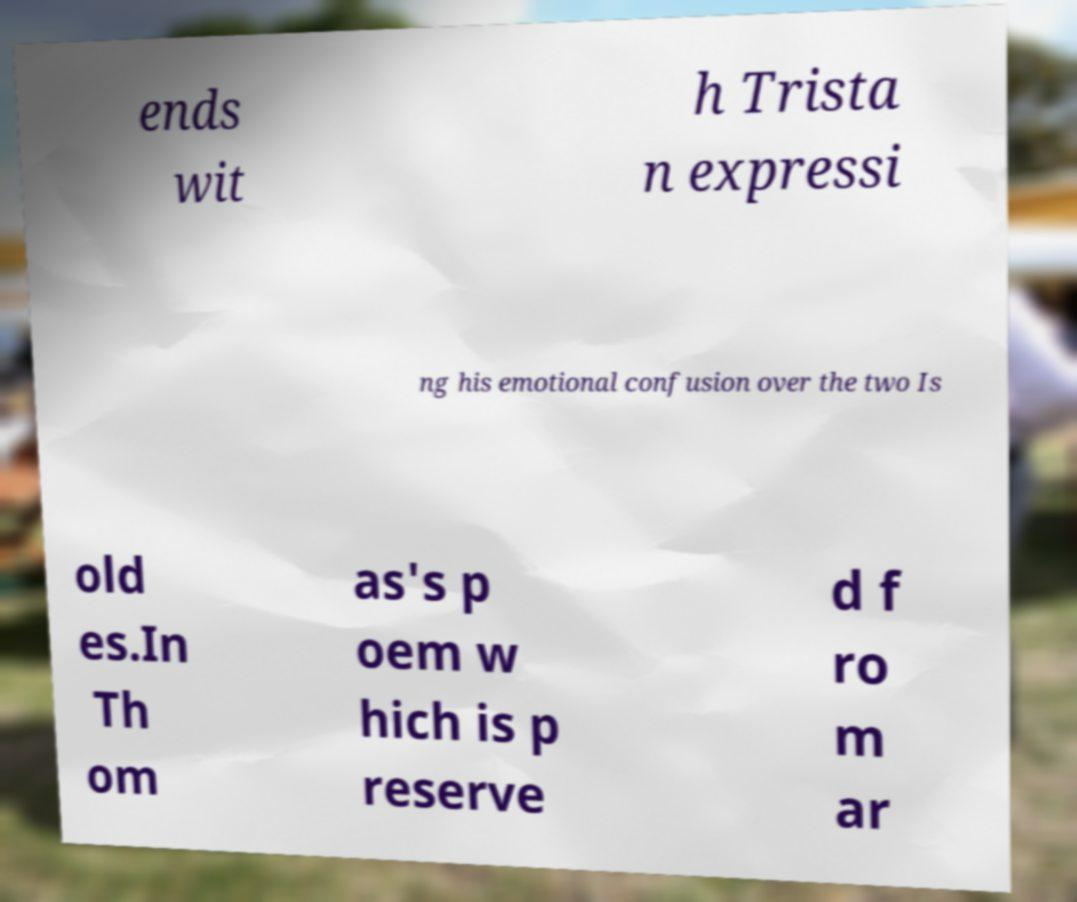Can you accurately transcribe the text from the provided image for me? ends wit h Trista n expressi ng his emotional confusion over the two Is old es.In Th om as's p oem w hich is p reserve d f ro m ar 